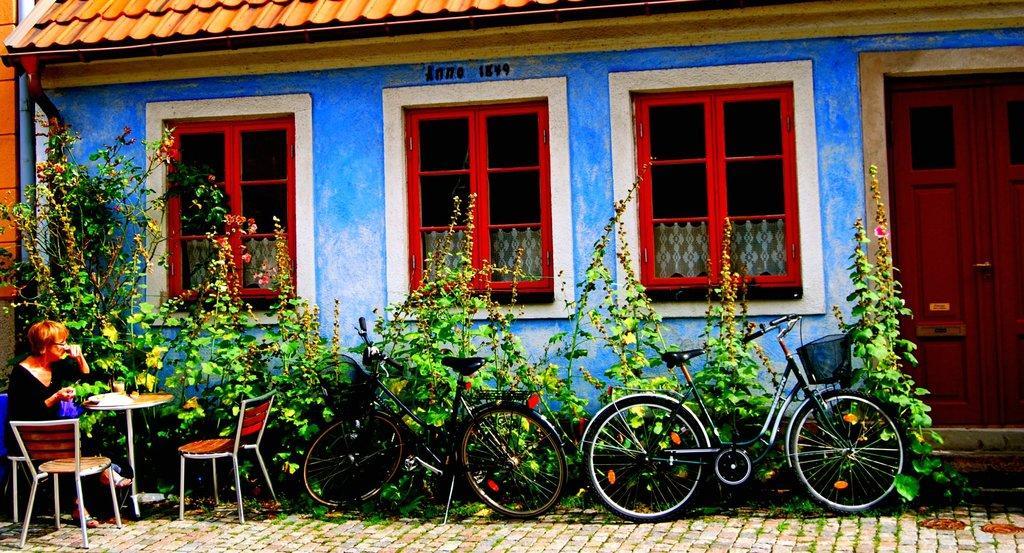How would you summarize this image in a sentence or two? As we can see in the image there is a blue color house with orange color roof and red color window,s in front of house there are plants, bicycles, chairs and table. On the left side there is a woman sitting on chair. On table there are glasses. 